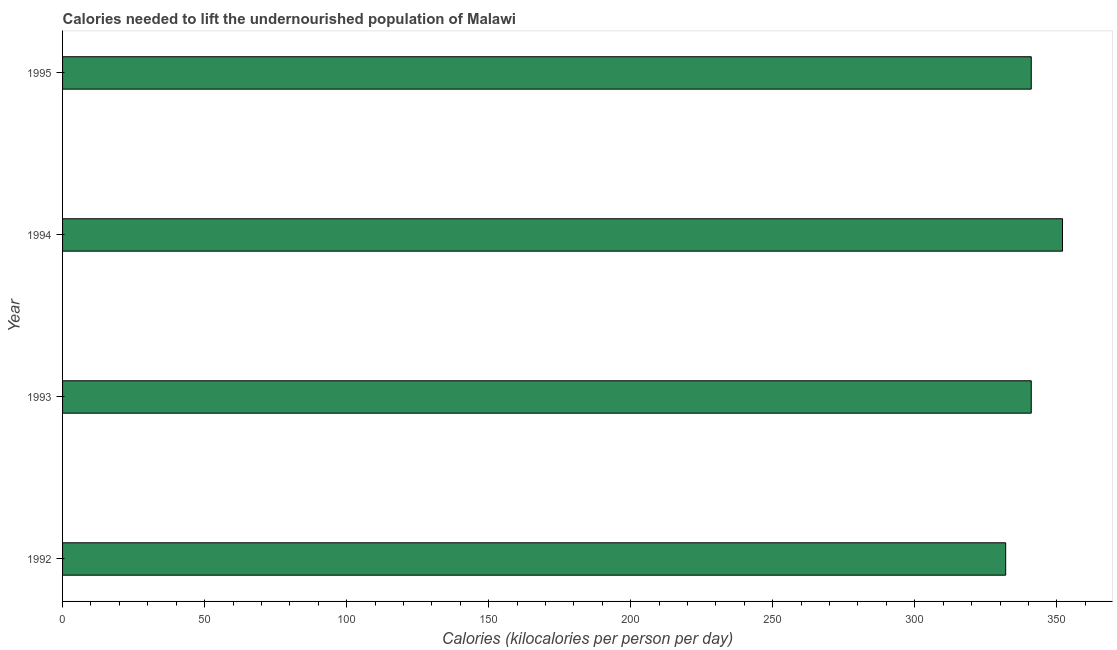Does the graph contain any zero values?
Provide a succinct answer. No. Does the graph contain grids?
Your response must be concise. No. What is the title of the graph?
Ensure brevity in your answer.  Calories needed to lift the undernourished population of Malawi. What is the label or title of the X-axis?
Provide a succinct answer. Calories (kilocalories per person per day). What is the depth of food deficit in 1995?
Offer a very short reply. 341. Across all years, what is the maximum depth of food deficit?
Give a very brief answer. 352. Across all years, what is the minimum depth of food deficit?
Offer a very short reply. 332. In which year was the depth of food deficit minimum?
Offer a very short reply. 1992. What is the sum of the depth of food deficit?
Keep it short and to the point. 1366. What is the difference between the depth of food deficit in 1992 and 1993?
Make the answer very short. -9. What is the average depth of food deficit per year?
Ensure brevity in your answer.  341. What is the median depth of food deficit?
Your answer should be compact. 341. In how many years, is the depth of food deficit greater than 180 kilocalories?
Ensure brevity in your answer.  4. Do a majority of the years between 1993 and 1995 (inclusive) have depth of food deficit greater than 340 kilocalories?
Provide a succinct answer. Yes. What is the ratio of the depth of food deficit in 1992 to that in 1994?
Your answer should be very brief. 0.94. Is the depth of food deficit in 1992 less than that in 1993?
Provide a succinct answer. Yes. Is the difference between the depth of food deficit in 1992 and 1994 greater than the difference between any two years?
Your answer should be compact. Yes. Is the sum of the depth of food deficit in 1992 and 1993 greater than the maximum depth of food deficit across all years?
Give a very brief answer. Yes. How many bars are there?
Your answer should be compact. 4. Are all the bars in the graph horizontal?
Offer a very short reply. Yes. What is the difference between two consecutive major ticks on the X-axis?
Offer a terse response. 50. Are the values on the major ticks of X-axis written in scientific E-notation?
Provide a short and direct response. No. What is the Calories (kilocalories per person per day) of 1992?
Offer a very short reply. 332. What is the Calories (kilocalories per person per day) in 1993?
Offer a very short reply. 341. What is the Calories (kilocalories per person per day) of 1994?
Offer a very short reply. 352. What is the Calories (kilocalories per person per day) of 1995?
Your answer should be compact. 341. What is the difference between the Calories (kilocalories per person per day) in 1993 and 1994?
Make the answer very short. -11. What is the difference between the Calories (kilocalories per person per day) in 1993 and 1995?
Keep it short and to the point. 0. What is the difference between the Calories (kilocalories per person per day) in 1994 and 1995?
Give a very brief answer. 11. What is the ratio of the Calories (kilocalories per person per day) in 1992 to that in 1993?
Offer a terse response. 0.97. What is the ratio of the Calories (kilocalories per person per day) in 1992 to that in 1994?
Offer a very short reply. 0.94. What is the ratio of the Calories (kilocalories per person per day) in 1993 to that in 1994?
Your response must be concise. 0.97. What is the ratio of the Calories (kilocalories per person per day) in 1994 to that in 1995?
Provide a short and direct response. 1.03. 